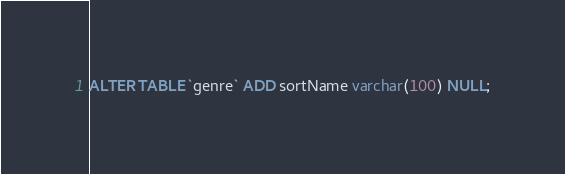Convert code to text. <code><loc_0><loc_0><loc_500><loc_500><_SQL_>ALTER TABLE `genre` ADD sortName varchar(100) NULL;
</code> 